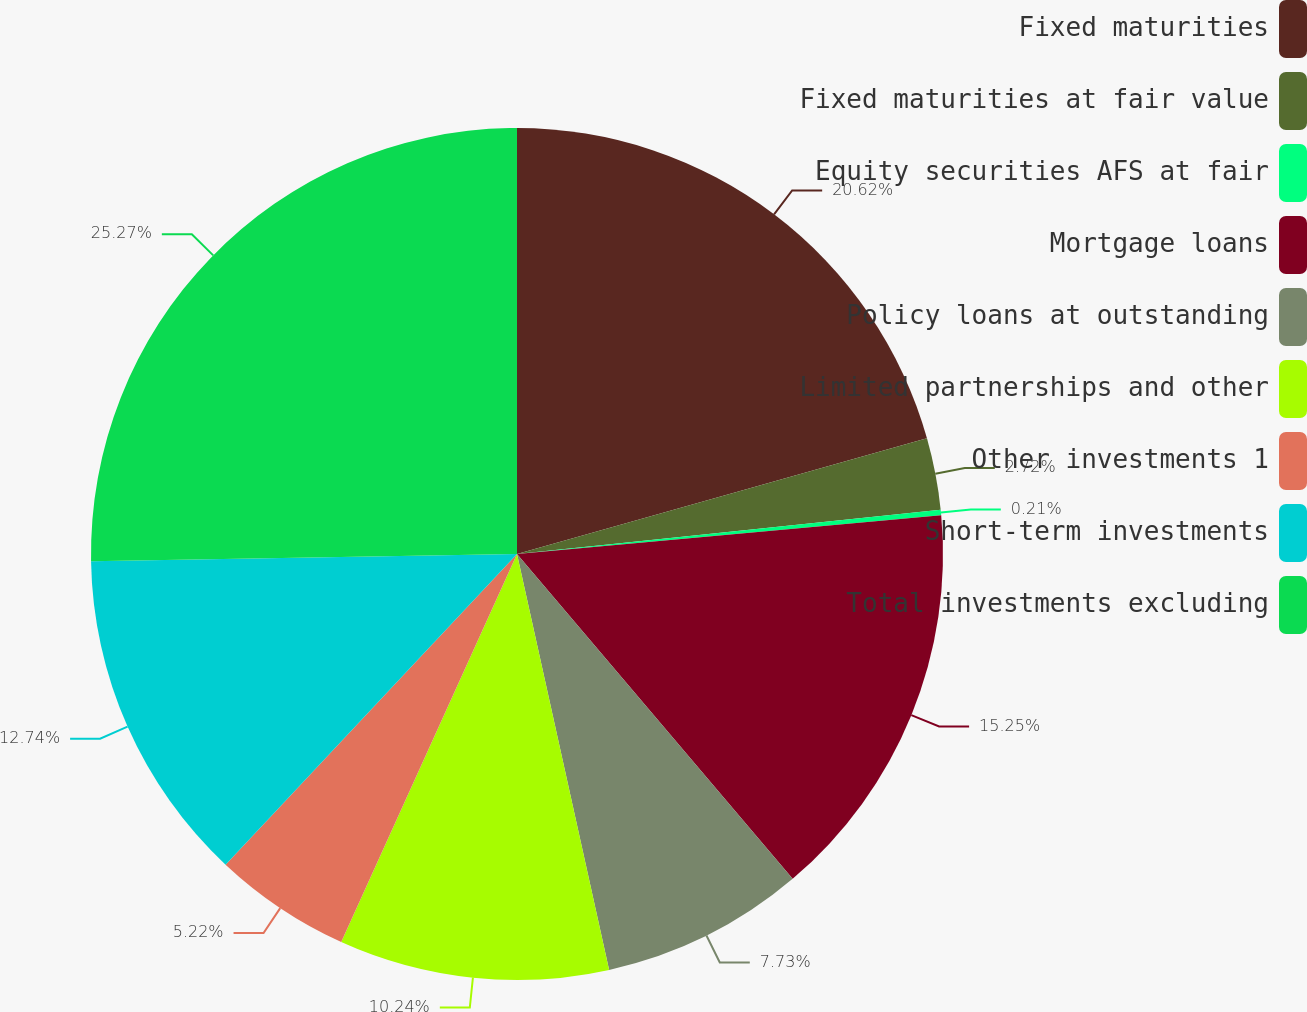Convert chart. <chart><loc_0><loc_0><loc_500><loc_500><pie_chart><fcel>Fixed maturities<fcel>Fixed maturities at fair value<fcel>Equity securities AFS at fair<fcel>Mortgage loans<fcel>Policy loans at outstanding<fcel>Limited partnerships and other<fcel>Other investments 1<fcel>Short-term investments<fcel>Total investments excluding<nl><fcel>20.62%<fcel>2.72%<fcel>0.21%<fcel>15.25%<fcel>7.73%<fcel>10.24%<fcel>5.22%<fcel>12.74%<fcel>25.27%<nl></chart> 